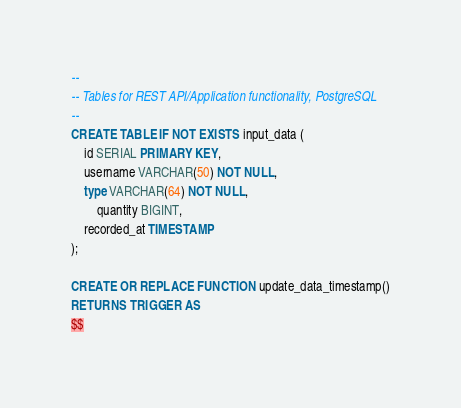Convert code to text. <code><loc_0><loc_0><loc_500><loc_500><_SQL_>--
-- Tables for REST API/Application functionality, PostgreSQL
--
CREATE TABLE IF NOT EXISTS input_data (
	id SERIAL PRIMARY KEY,
	username VARCHAR(50) NOT NULL,
	type VARCHAR(64) NOT NULL,
        quantity BIGINT,
	recorded_at TIMESTAMP
);

CREATE OR REPLACE FUNCTION update_data_timestamp()
RETURNS TRIGGER AS
$$</code> 